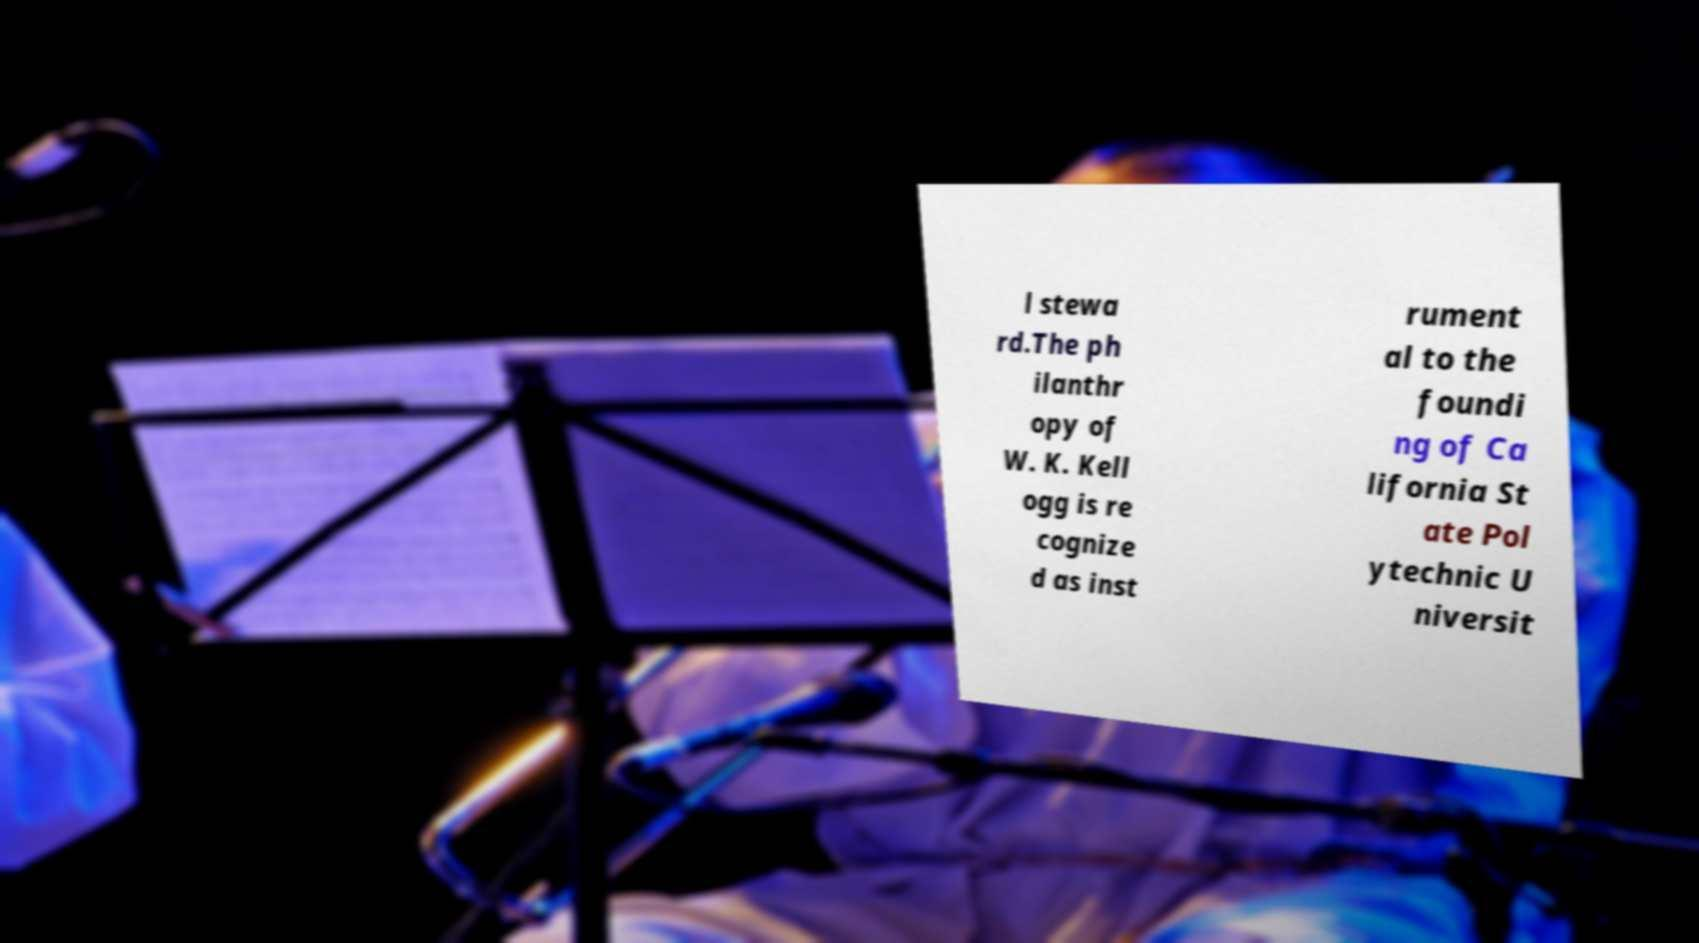Please read and relay the text visible in this image. What does it say? l stewa rd.The ph ilanthr opy of W. K. Kell ogg is re cognize d as inst rument al to the foundi ng of Ca lifornia St ate Pol ytechnic U niversit 